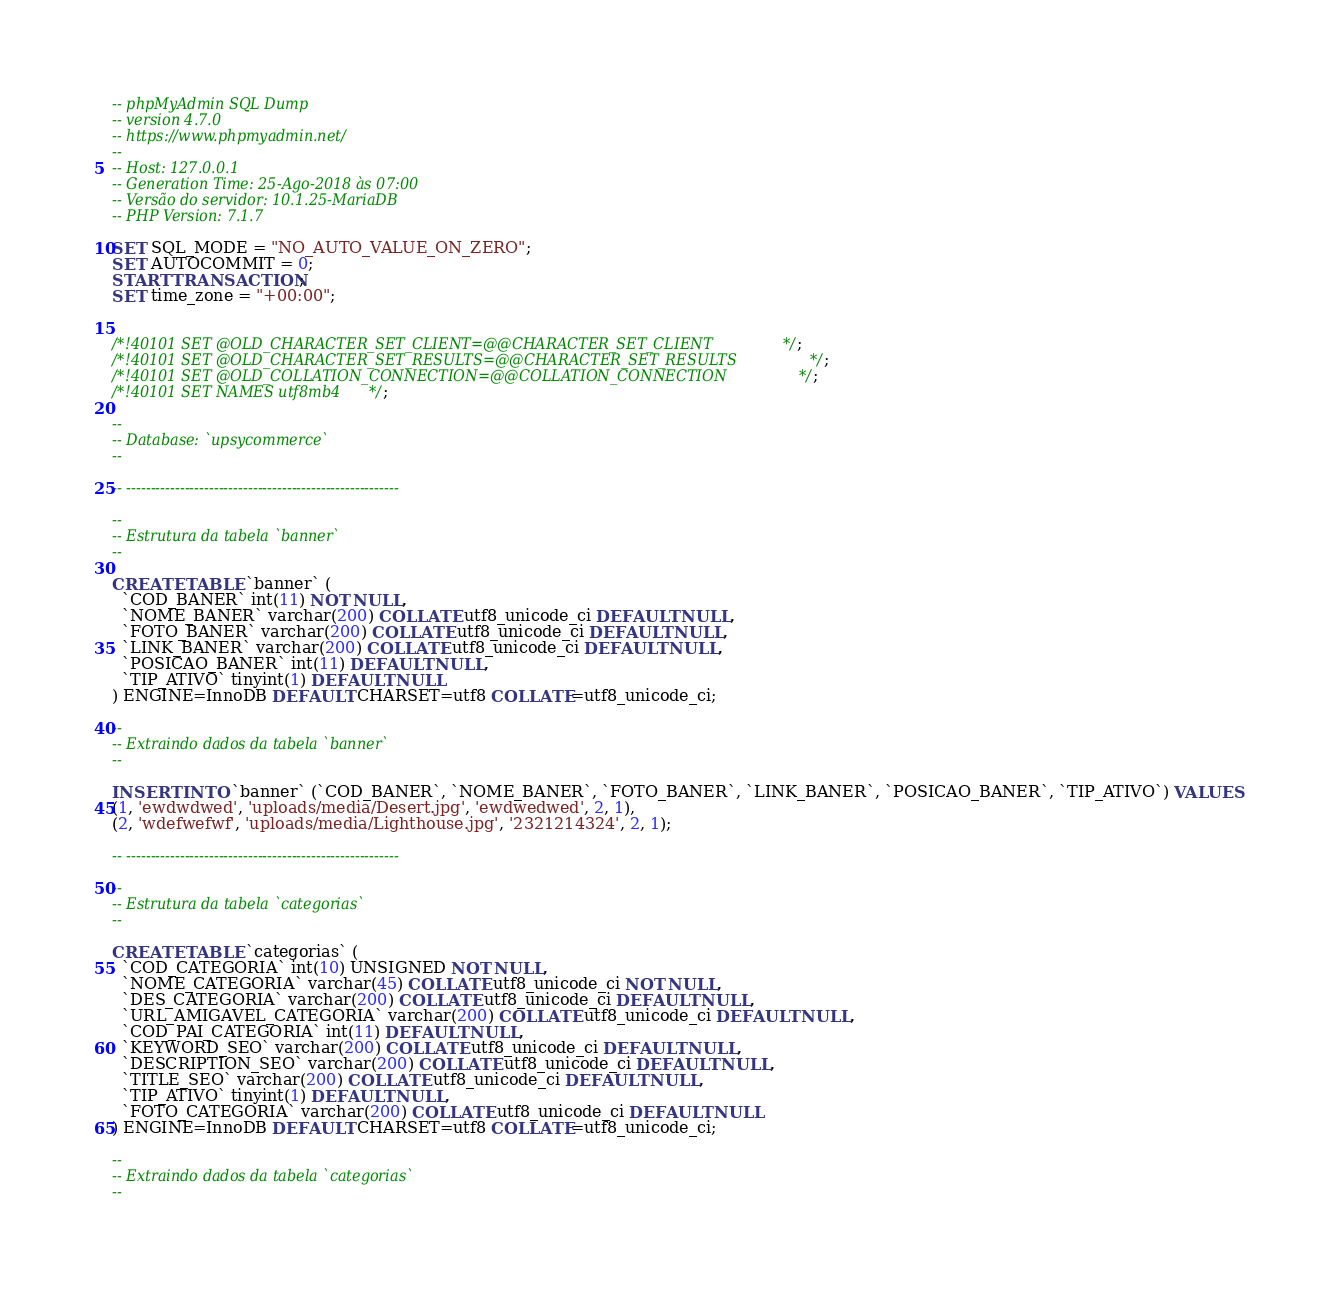<code> <loc_0><loc_0><loc_500><loc_500><_SQL_>-- phpMyAdmin SQL Dump
-- version 4.7.0
-- https://www.phpmyadmin.net/
--
-- Host: 127.0.0.1
-- Generation Time: 25-Ago-2018 às 07:00
-- Versão do servidor: 10.1.25-MariaDB
-- PHP Version: 7.1.7

SET SQL_MODE = "NO_AUTO_VALUE_ON_ZERO";
SET AUTOCOMMIT = 0;
START TRANSACTION;
SET time_zone = "+00:00";


/*!40101 SET @OLD_CHARACTER_SET_CLIENT=@@CHARACTER_SET_CLIENT */;
/*!40101 SET @OLD_CHARACTER_SET_RESULTS=@@CHARACTER_SET_RESULTS */;
/*!40101 SET @OLD_COLLATION_CONNECTION=@@COLLATION_CONNECTION */;
/*!40101 SET NAMES utf8mb4 */;

--
-- Database: `upsycommerce`
--

-- --------------------------------------------------------

--
-- Estrutura da tabela `banner`
--

CREATE TABLE `banner` (
  `COD_BANER` int(11) NOT NULL,
  `NOME_BANER` varchar(200) COLLATE utf8_unicode_ci DEFAULT NULL,
  `FOTO_BANER` varchar(200) COLLATE utf8_unicode_ci DEFAULT NULL,
  `LINK_BANER` varchar(200) COLLATE utf8_unicode_ci DEFAULT NULL,
  `POSICAO_BANER` int(11) DEFAULT NULL,
  `TIP_ATIVO` tinyint(1) DEFAULT NULL
) ENGINE=InnoDB DEFAULT CHARSET=utf8 COLLATE=utf8_unicode_ci;

--
-- Extraindo dados da tabela `banner`
--

INSERT INTO `banner` (`COD_BANER`, `NOME_BANER`, `FOTO_BANER`, `LINK_BANER`, `POSICAO_BANER`, `TIP_ATIVO`) VALUES
(1, 'ewdwdwed', 'uploads/media/Desert.jpg', 'ewdwedwed', 2, 1),
(2, 'wdefwefwf', 'uploads/media/Lighthouse.jpg', '2321214324', 2, 1);

-- --------------------------------------------------------

--
-- Estrutura da tabela `categorias`
--

CREATE TABLE `categorias` (
  `COD_CATEGORIA` int(10) UNSIGNED NOT NULL,
  `NOME_CATEGORIA` varchar(45) COLLATE utf8_unicode_ci NOT NULL,
  `DES_CATEGORIA` varchar(200) COLLATE utf8_unicode_ci DEFAULT NULL,
  `URL_AMIGAVEL_CATEGORIA` varchar(200) COLLATE utf8_unicode_ci DEFAULT NULL,
  `COD_PAI_CATEGORIA` int(11) DEFAULT NULL,
  `KEYWORD_SEO` varchar(200) COLLATE utf8_unicode_ci DEFAULT NULL,
  `DESCRIPTION_SEO` varchar(200) COLLATE utf8_unicode_ci DEFAULT NULL,
  `TITLE_SEO` varchar(200) COLLATE utf8_unicode_ci DEFAULT NULL,
  `TIP_ATIVO` tinyint(1) DEFAULT NULL,
  `FOTO_CATEGORIA` varchar(200) COLLATE utf8_unicode_ci DEFAULT NULL
) ENGINE=InnoDB DEFAULT CHARSET=utf8 COLLATE=utf8_unicode_ci;

--
-- Extraindo dados da tabela `categorias`
--
</code> 